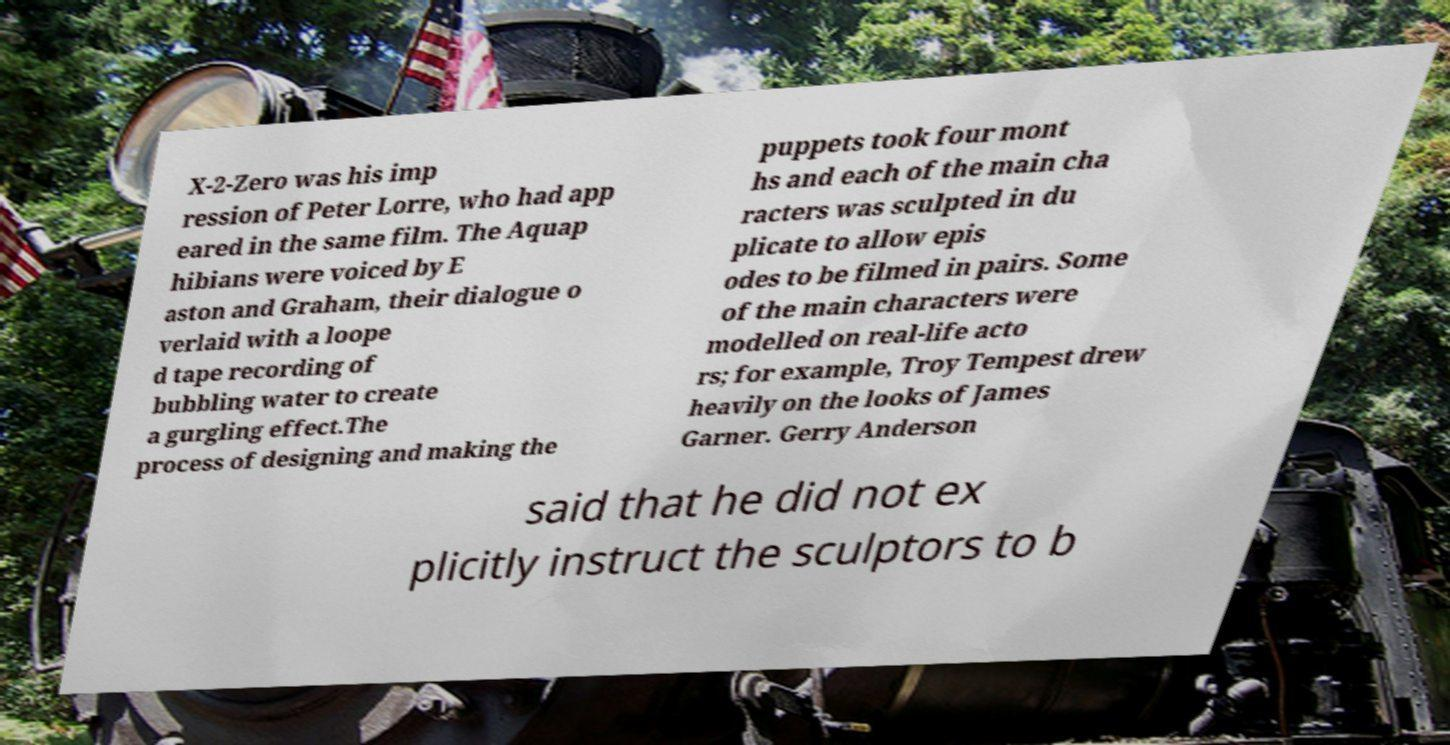Can you read and provide the text displayed in the image?This photo seems to have some interesting text. Can you extract and type it out for me? X-2-Zero was his imp ression of Peter Lorre, who had app eared in the same film. The Aquap hibians were voiced by E aston and Graham, their dialogue o verlaid with a loope d tape recording of bubbling water to create a gurgling effect.The process of designing and making the puppets took four mont hs and each of the main cha racters was sculpted in du plicate to allow epis odes to be filmed in pairs. Some of the main characters were modelled on real-life acto rs; for example, Troy Tempest drew heavily on the looks of James Garner. Gerry Anderson said that he did not ex plicitly instruct the sculptors to b 